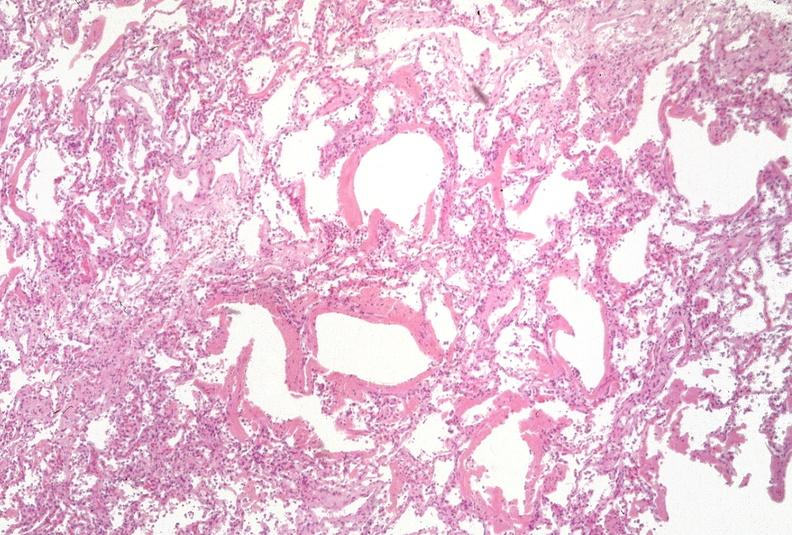s spinal column present?
Answer the question using a single word or phrase. No 